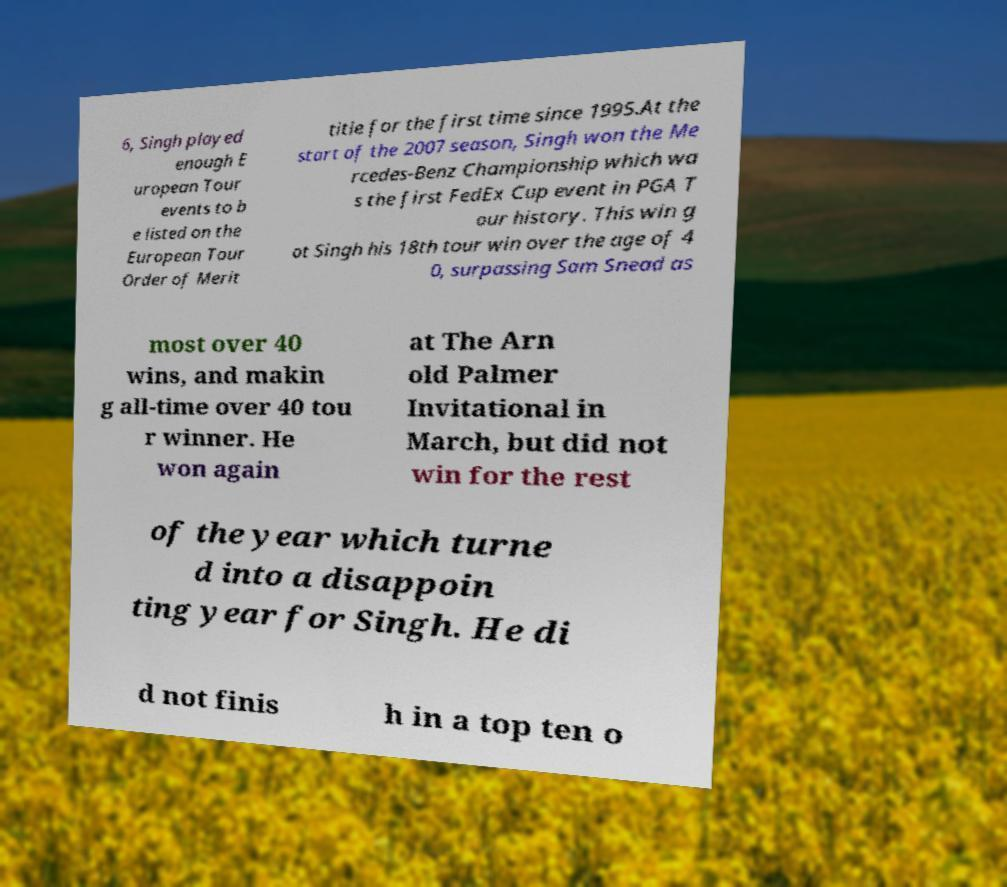Could you extract and type out the text from this image? 6, Singh played enough E uropean Tour events to b e listed on the European Tour Order of Merit title for the first time since 1995.At the start of the 2007 season, Singh won the Me rcedes-Benz Championship which wa s the first FedEx Cup event in PGA T our history. This win g ot Singh his 18th tour win over the age of 4 0, surpassing Sam Snead as most over 40 wins, and makin g all-time over 40 tou r winner. He won again at The Arn old Palmer Invitational in March, but did not win for the rest of the year which turne d into a disappoin ting year for Singh. He di d not finis h in a top ten o 